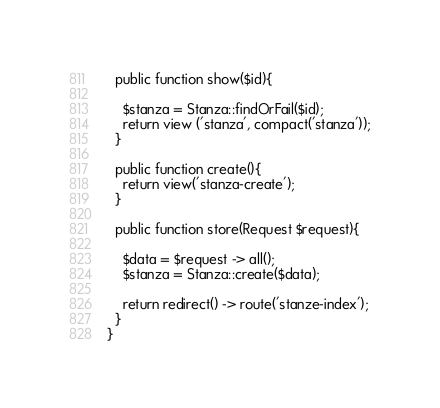<code> <loc_0><loc_0><loc_500><loc_500><_PHP_>
  public function show($id){

    $stanza = Stanza::findOrFail($id);
    return view ('stanza', compact('stanza'));
  }

  public function create(){
    return view('stanza-create');
  }

  public function store(Request $request){

    $data = $request -> all();
    $stanza = Stanza::create($data);

    return redirect() -> route('stanze-index');
  }
}
</code> 